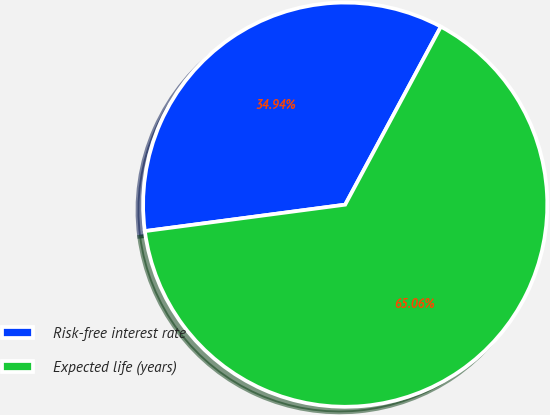Convert chart to OTSL. <chart><loc_0><loc_0><loc_500><loc_500><pie_chart><fcel>Risk-free interest rate<fcel>Expected life (years)<nl><fcel>34.94%<fcel>65.06%<nl></chart> 